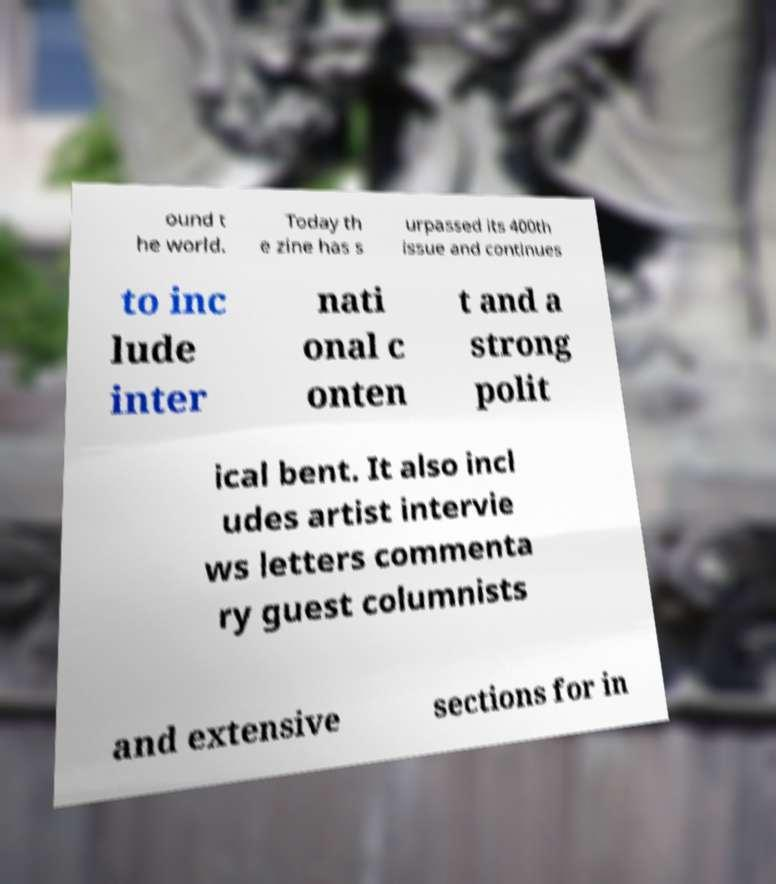Could you assist in decoding the text presented in this image and type it out clearly? ound t he world. Today th e zine has s urpassed its 400th issue and continues to inc lude inter nati onal c onten t and a strong polit ical bent. It also incl udes artist intervie ws letters commenta ry guest columnists and extensive sections for in 